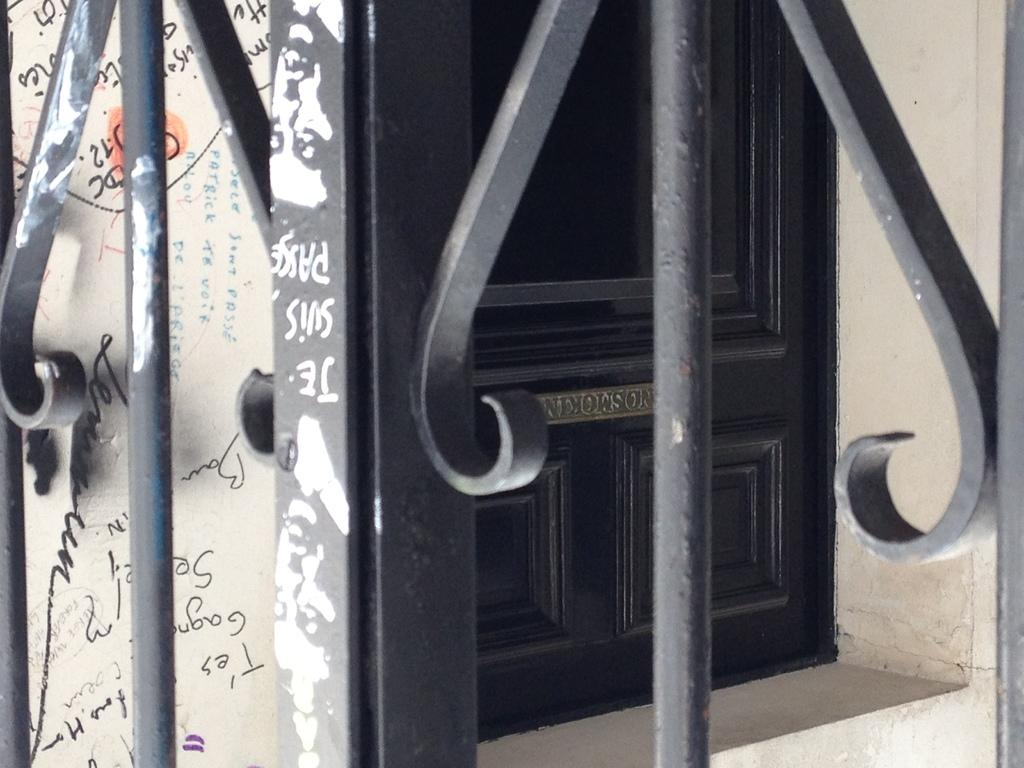What type of structure can be seen in the image? There is a door in the image. What else is present in the image besides the door? There is a wall and a fence in the image. How many mice can be seen playing near the fence in the image? There are no mice present in the image; it only features a door, wall, and fence. Is there a lake visible in the image? No, there is no lake present in the image. 